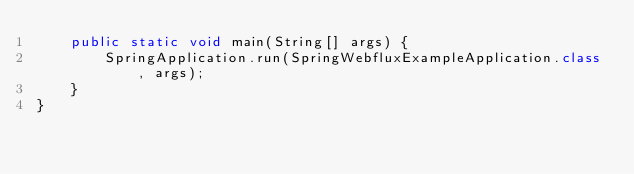Convert code to text. <code><loc_0><loc_0><loc_500><loc_500><_Java_>	public static void main(String[] args) {
		SpringApplication.run(SpringWebfluxExampleApplication.class, args);
	}
}
</code> 